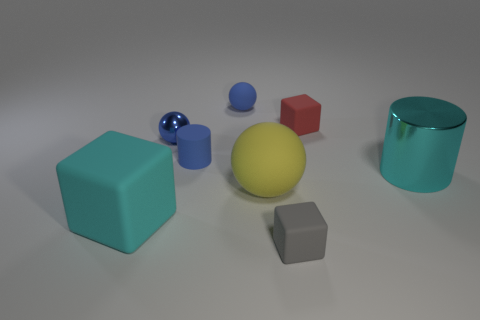What number of other things are there of the same size as the blue matte cylinder?
Your response must be concise. 4. Is the number of tiny yellow metallic balls less than the number of small red rubber blocks?
Ensure brevity in your answer.  Yes. What shape is the yellow thing?
Your answer should be compact. Sphere. Does the rubber ball behind the metallic ball have the same color as the large rubber block?
Provide a succinct answer. No. What is the shape of the object that is both behind the tiny metal object and to the right of the gray matte object?
Offer a very short reply. Cube. What color is the shiny object that is left of the gray block?
Your answer should be compact. Blue. Is there any other thing that has the same color as the tiny metal object?
Offer a very short reply. Yes. Do the cyan metal cylinder and the blue cylinder have the same size?
Your answer should be compact. No. What is the size of the object that is in front of the large cyan metallic cylinder and on the left side of the blue rubber cylinder?
Your answer should be compact. Large. How many cyan cylinders are the same material as the gray cube?
Offer a very short reply. 0. 